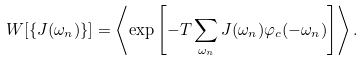Convert formula to latex. <formula><loc_0><loc_0><loc_500><loc_500>W [ \{ J ( \omega _ { n } ) \} ] = \left \langle \exp \left [ - T \sum _ { \omega _ { n } } J ( \omega _ { n } ) \varphi _ { c } ( - \omega _ { n } ) \right ] \right \rangle .</formula> 